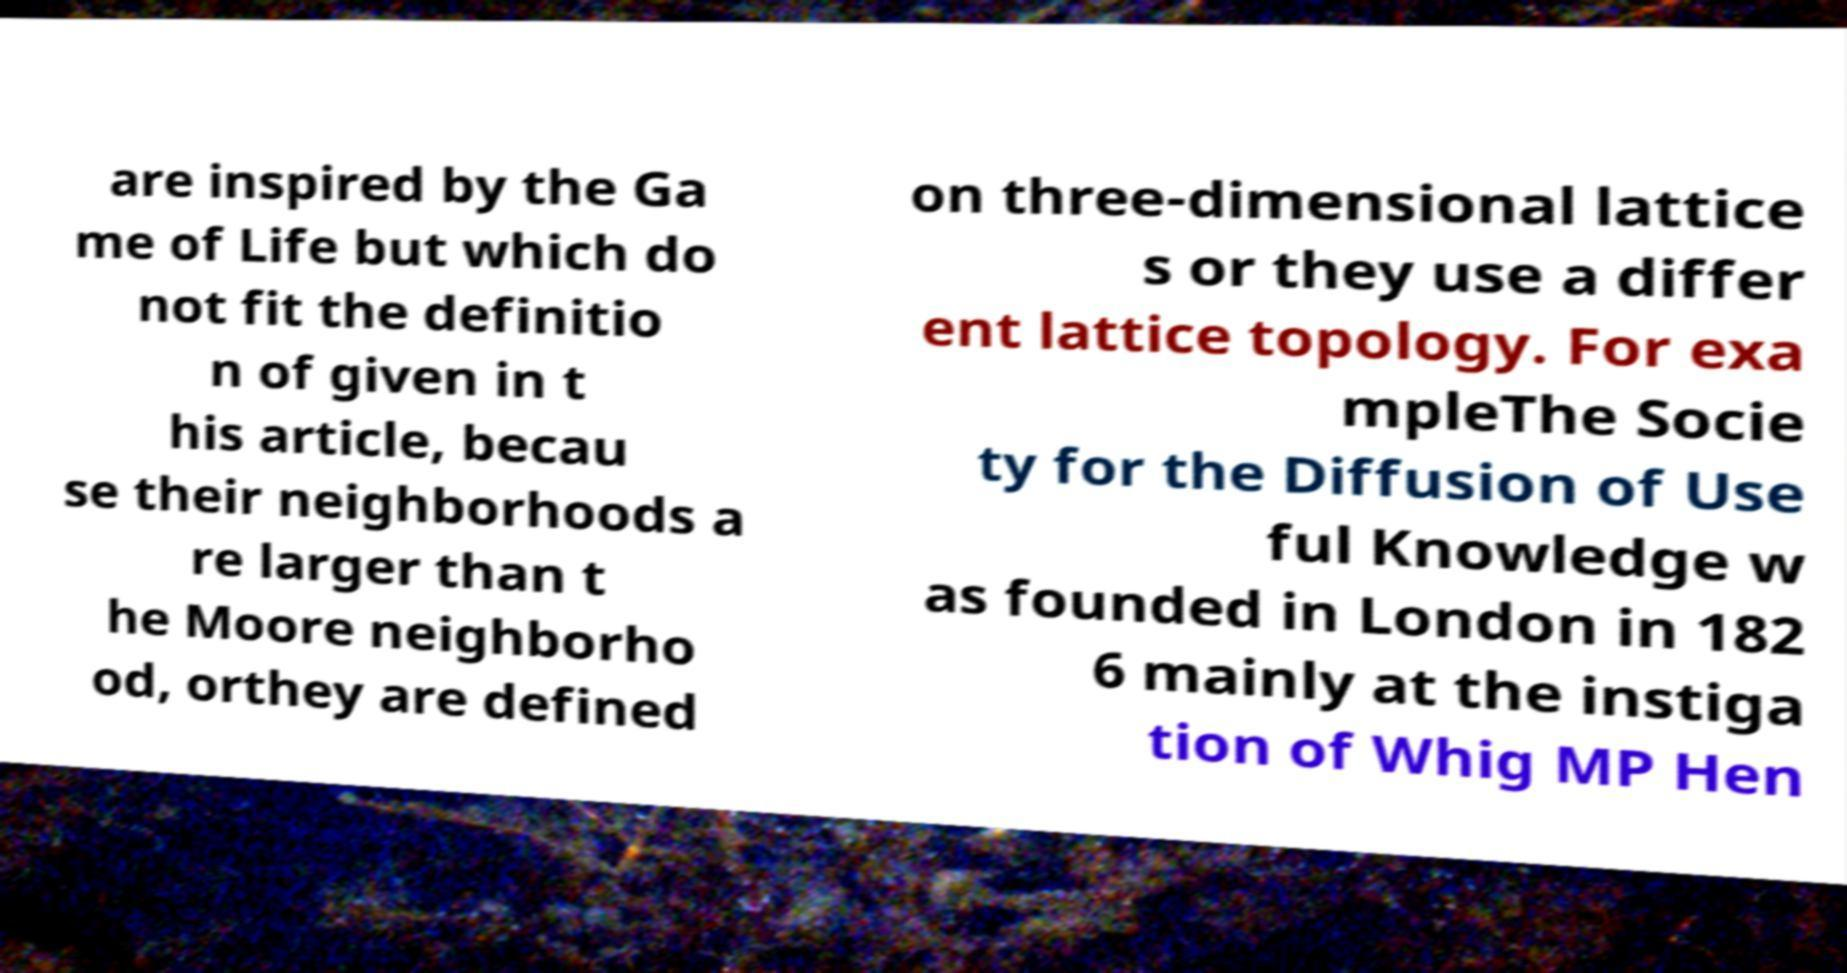Please read and relay the text visible in this image. What does it say? are inspired by the Ga me of Life but which do not fit the definitio n of given in t his article, becau se their neighborhoods a re larger than t he Moore neighborho od, orthey are defined on three-dimensional lattice s or they use a differ ent lattice topology. For exa mpleThe Socie ty for the Diffusion of Use ful Knowledge w as founded in London in 182 6 mainly at the instiga tion of Whig MP Hen 